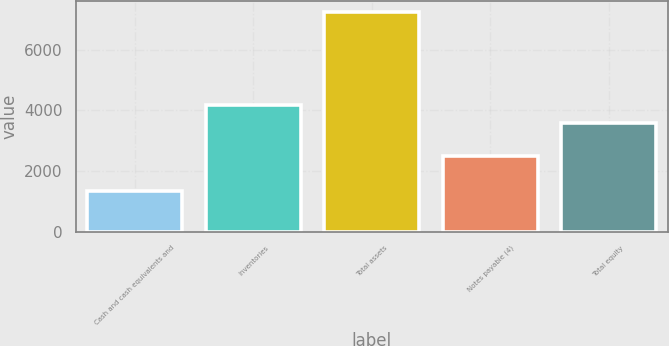Convert chart. <chart><loc_0><loc_0><loc_500><loc_500><bar_chart><fcel>Cash and cash equivalents and<fcel>Inventories<fcel>Total assets<fcel>Notes payable (4)<fcel>Total equity<nl><fcel>1345.7<fcel>4184.95<fcel>7248.2<fcel>2493.1<fcel>3594.7<nl></chart> 